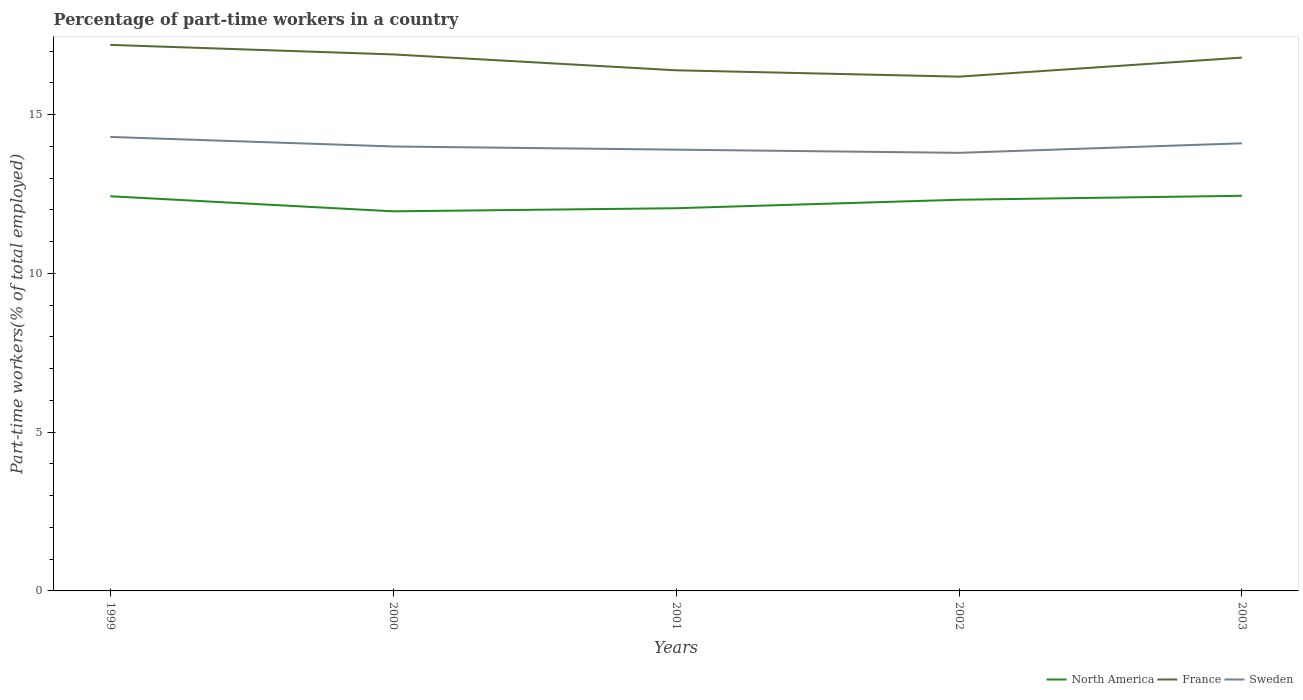Across all years, what is the maximum percentage of part-time workers in Sweden?
Give a very brief answer. 13.8. What is the total percentage of part-time workers in France in the graph?
Provide a succinct answer. 0.7. What is the difference between the highest and the second highest percentage of part-time workers in North America?
Make the answer very short. 0.49. What is the difference between the highest and the lowest percentage of part-time workers in France?
Keep it short and to the point. 3. Is the percentage of part-time workers in Sweden strictly greater than the percentage of part-time workers in North America over the years?
Your response must be concise. No. How many years are there in the graph?
Keep it short and to the point. 5. What is the difference between two consecutive major ticks on the Y-axis?
Your answer should be very brief. 5. How many legend labels are there?
Your answer should be compact. 3. How are the legend labels stacked?
Ensure brevity in your answer.  Horizontal. What is the title of the graph?
Provide a succinct answer. Percentage of part-time workers in a country. Does "Dominican Republic" appear as one of the legend labels in the graph?
Your answer should be compact. No. What is the label or title of the X-axis?
Offer a terse response. Years. What is the label or title of the Y-axis?
Your answer should be compact. Part-time workers(% of total employed). What is the Part-time workers(% of total employed) of North America in 1999?
Offer a terse response. 12.43. What is the Part-time workers(% of total employed) in France in 1999?
Offer a very short reply. 17.2. What is the Part-time workers(% of total employed) in Sweden in 1999?
Offer a very short reply. 14.3. What is the Part-time workers(% of total employed) of North America in 2000?
Offer a terse response. 11.96. What is the Part-time workers(% of total employed) of France in 2000?
Your answer should be compact. 16.9. What is the Part-time workers(% of total employed) of North America in 2001?
Ensure brevity in your answer.  12.06. What is the Part-time workers(% of total employed) in France in 2001?
Offer a terse response. 16.4. What is the Part-time workers(% of total employed) of Sweden in 2001?
Offer a terse response. 13.9. What is the Part-time workers(% of total employed) in North America in 2002?
Provide a succinct answer. 12.32. What is the Part-time workers(% of total employed) of France in 2002?
Provide a succinct answer. 16.2. What is the Part-time workers(% of total employed) in Sweden in 2002?
Make the answer very short. 13.8. What is the Part-time workers(% of total employed) in North America in 2003?
Ensure brevity in your answer.  12.45. What is the Part-time workers(% of total employed) in France in 2003?
Provide a short and direct response. 16.8. What is the Part-time workers(% of total employed) of Sweden in 2003?
Keep it short and to the point. 14.1. Across all years, what is the maximum Part-time workers(% of total employed) in North America?
Offer a terse response. 12.45. Across all years, what is the maximum Part-time workers(% of total employed) of France?
Make the answer very short. 17.2. Across all years, what is the maximum Part-time workers(% of total employed) in Sweden?
Keep it short and to the point. 14.3. Across all years, what is the minimum Part-time workers(% of total employed) of North America?
Keep it short and to the point. 11.96. Across all years, what is the minimum Part-time workers(% of total employed) of France?
Offer a very short reply. 16.2. Across all years, what is the minimum Part-time workers(% of total employed) in Sweden?
Keep it short and to the point. 13.8. What is the total Part-time workers(% of total employed) in North America in the graph?
Make the answer very short. 61.21. What is the total Part-time workers(% of total employed) of France in the graph?
Keep it short and to the point. 83.5. What is the total Part-time workers(% of total employed) in Sweden in the graph?
Ensure brevity in your answer.  70.1. What is the difference between the Part-time workers(% of total employed) of North America in 1999 and that in 2000?
Provide a short and direct response. 0.48. What is the difference between the Part-time workers(% of total employed) in North America in 1999 and that in 2001?
Provide a succinct answer. 0.38. What is the difference between the Part-time workers(% of total employed) of Sweden in 1999 and that in 2001?
Provide a short and direct response. 0.4. What is the difference between the Part-time workers(% of total employed) of North America in 1999 and that in 2002?
Your answer should be compact. 0.11. What is the difference between the Part-time workers(% of total employed) in France in 1999 and that in 2002?
Provide a succinct answer. 1. What is the difference between the Part-time workers(% of total employed) of North America in 1999 and that in 2003?
Offer a terse response. -0.01. What is the difference between the Part-time workers(% of total employed) of France in 1999 and that in 2003?
Ensure brevity in your answer.  0.4. What is the difference between the Part-time workers(% of total employed) of North America in 2000 and that in 2001?
Keep it short and to the point. -0.1. What is the difference between the Part-time workers(% of total employed) of Sweden in 2000 and that in 2001?
Your response must be concise. 0.1. What is the difference between the Part-time workers(% of total employed) of North America in 2000 and that in 2002?
Your answer should be very brief. -0.36. What is the difference between the Part-time workers(% of total employed) in North America in 2000 and that in 2003?
Ensure brevity in your answer.  -0.49. What is the difference between the Part-time workers(% of total employed) in North America in 2001 and that in 2002?
Offer a very short reply. -0.27. What is the difference between the Part-time workers(% of total employed) in Sweden in 2001 and that in 2002?
Offer a terse response. 0.1. What is the difference between the Part-time workers(% of total employed) of North America in 2001 and that in 2003?
Your response must be concise. -0.39. What is the difference between the Part-time workers(% of total employed) of France in 2001 and that in 2003?
Ensure brevity in your answer.  -0.4. What is the difference between the Part-time workers(% of total employed) of Sweden in 2001 and that in 2003?
Provide a succinct answer. -0.2. What is the difference between the Part-time workers(% of total employed) in North America in 2002 and that in 2003?
Your answer should be compact. -0.13. What is the difference between the Part-time workers(% of total employed) in Sweden in 2002 and that in 2003?
Keep it short and to the point. -0.3. What is the difference between the Part-time workers(% of total employed) of North America in 1999 and the Part-time workers(% of total employed) of France in 2000?
Make the answer very short. -4.47. What is the difference between the Part-time workers(% of total employed) in North America in 1999 and the Part-time workers(% of total employed) in Sweden in 2000?
Keep it short and to the point. -1.57. What is the difference between the Part-time workers(% of total employed) in North America in 1999 and the Part-time workers(% of total employed) in France in 2001?
Offer a very short reply. -3.97. What is the difference between the Part-time workers(% of total employed) in North America in 1999 and the Part-time workers(% of total employed) in Sweden in 2001?
Offer a terse response. -1.47. What is the difference between the Part-time workers(% of total employed) in France in 1999 and the Part-time workers(% of total employed) in Sweden in 2001?
Give a very brief answer. 3.3. What is the difference between the Part-time workers(% of total employed) in North America in 1999 and the Part-time workers(% of total employed) in France in 2002?
Your answer should be very brief. -3.77. What is the difference between the Part-time workers(% of total employed) in North America in 1999 and the Part-time workers(% of total employed) in Sweden in 2002?
Your answer should be very brief. -1.37. What is the difference between the Part-time workers(% of total employed) of North America in 1999 and the Part-time workers(% of total employed) of France in 2003?
Keep it short and to the point. -4.37. What is the difference between the Part-time workers(% of total employed) in North America in 1999 and the Part-time workers(% of total employed) in Sweden in 2003?
Give a very brief answer. -1.67. What is the difference between the Part-time workers(% of total employed) in North America in 2000 and the Part-time workers(% of total employed) in France in 2001?
Make the answer very short. -4.44. What is the difference between the Part-time workers(% of total employed) of North America in 2000 and the Part-time workers(% of total employed) of Sweden in 2001?
Ensure brevity in your answer.  -1.94. What is the difference between the Part-time workers(% of total employed) in North America in 2000 and the Part-time workers(% of total employed) in France in 2002?
Provide a succinct answer. -4.24. What is the difference between the Part-time workers(% of total employed) in North America in 2000 and the Part-time workers(% of total employed) in Sweden in 2002?
Your answer should be compact. -1.84. What is the difference between the Part-time workers(% of total employed) in North America in 2000 and the Part-time workers(% of total employed) in France in 2003?
Your answer should be very brief. -4.84. What is the difference between the Part-time workers(% of total employed) in North America in 2000 and the Part-time workers(% of total employed) in Sweden in 2003?
Make the answer very short. -2.14. What is the difference between the Part-time workers(% of total employed) in France in 2000 and the Part-time workers(% of total employed) in Sweden in 2003?
Your response must be concise. 2.8. What is the difference between the Part-time workers(% of total employed) of North America in 2001 and the Part-time workers(% of total employed) of France in 2002?
Give a very brief answer. -4.14. What is the difference between the Part-time workers(% of total employed) of North America in 2001 and the Part-time workers(% of total employed) of Sweden in 2002?
Your answer should be compact. -1.74. What is the difference between the Part-time workers(% of total employed) in France in 2001 and the Part-time workers(% of total employed) in Sweden in 2002?
Ensure brevity in your answer.  2.6. What is the difference between the Part-time workers(% of total employed) in North America in 2001 and the Part-time workers(% of total employed) in France in 2003?
Offer a terse response. -4.74. What is the difference between the Part-time workers(% of total employed) of North America in 2001 and the Part-time workers(% of total employed) of Sweden in 2003?
Offer a terse response. -2.04. What is the difference between the Part-time workers(% of total employed) of France in 2001 and the Part-time workers(% of total employed) of Sweden in 2003?
Offer a terse response. 2.3. What is the difference between the Part-time workers(% of total employed) in North America in 2002 and the Part-time workers(% of total employed) in France in 2003?
Your answer should be compact. -4.48. What is the difference between the Part-time workers(% of total employed) in North America in 2002 and the Part-time workers(% of total employed) in Sweden in 2003?
Provide a succinct answer. -1.78. What is the average Part-time workers(% of total employed) in North America per year?
Offer a terse response. 12.24. What is the average Part-time workers(% of total employed) of Sweden per year?
Provide a succinct answer. 14.02. In the year 1999, what is the difference between the Part-time workers(% of total employed) of North America and Part-time workers(% of total employed) of France?
Your response must be concise. -4.77. In the year 1999, what is the difference between the Part-time workers(% of total employed) in North America and Part-time workers(% of total employed) in Sweden?
Offer a very short reply. -1.87. In the year 2000, what is the difference between the Part-time workers(% of total employed) of North America and Part-time workers(% of total employed) of France?
Your response must be concise. -4.94. In the year 2000, what is the difference between the Part-time workers(% of total employed) in North America and Part-time workers(% of total employed) in Sweden?
Provide a short and direct response. -2.04. In the year 2001, what is the difference between the Part-time workers(% of total employed) in North America and Part-time workers(% of total employed) in France?
Offer a terse response. -4.34. In the year 2001, what is the difference between the Part-time workers(% of total employed) in North America and Part-time workers(% of total employed) in Sweden?
Ensure brevity in your answer.  -1.84. In the year 2002, what is the difference between the Part-time workers(% of total employed) of North America and Part-time workers(% of total employed) of France?
Offer a very short reply. -3.88. In the year 2002, what is the difference between the Part-time workers(% of total employed) in North America and Part-time workers(% of total employed) in Sweden?
Give a very brief answer. -1.48. In the year 2002, what is the difference between the Part-time workers(% of total employed) in France and Part-time workers(% of total employed) in Sweden?
Provide a succinct answer. 2.4. In the year 2003, what is the difference between the Part-time workers(% of total employed) in North America and Part-time workers(% of total employed) in France?
Your answer should be very brief. -4.35. In the year 2003, what is the difference between the Part-time workers(% of total employed) of North America and Part-time workers(% of total employed) of Sweden?
Offer a terse response. -1.65. In the year 2003, what is the difference between the Part-time workers(% of total employed) in France and Part-time workers(% of total employed) in Sweden?
Your response must be concise. 2.7. What is the ratio of the Part-time workers(% of total employed) in North America in 1999 to that in 2000?
Your answer should be very brief. 1.04. What is the ratio of the Part-time workers(% of total employed) in France in 1999 to that in 2000?
Offer a very short reply. 1.02. What is the ratio of the Part-time workers(% of total employed) in Sweden in 1999 to that in 2000?
Make the answer very short. 1.02. What is the ratio of the Part-time workers(% of total employed) of North America in 1999 to that in 2001?
Your answer should be compact. 1.03. What is the ratio of the Part-time workers(% of total employed) of France in 1999 to that in 2001?
Provide a short and direct response. 1.05. What is the ratio of the Part-time workers(% of total employed) in Sweden in 1999 to that in 2001?
Make the answer very short. 1.03. What is the ratio of the Part-time workers(% of total employed) in North America in 1999 to that in 2002?
Offer a terse response. 1.01. What is the ratio of the Part-time workers(% of total employed) in France in 1999 to that in 2002?
Ensure brevity in your answer.  1.06. What is the ratio of the Part-time workers(% of total employed) of Sweden in 1999 to that in 2002?
Your answer should be compact. 1.04. What is the ratio of the Part-time workers(% of total employed) in France in 1999 to that in 2003?
Make the answer very short. 1.02. What is the ratio of the Part-time workers(% of total employed) in Sweden in 1999 to that in 2003?
Your answer should be compact. 1.01. What is the ratio of the Part-time workers(% of total employed) of North America in 2000 to that in 2001?
Offer a terse response. 0.99. What is the ratio of the Part-time workers(% of total employed) of France in 2000 to that in 2001?
Give a very brief answer. 1.03. What is the ratio of the Part-time workers(% of total employed) in North America in 2000 to that in 2002?
Your answer should be compact. 0.97. What is the ratio of the Part-time workers(% of total employed) of France in 2000 to that in 2002?
Offer a terse response. 1.04. What is the ratio of the Part-time workers(% of total employed) of Sweden in 2000 to that in 2002?
Ensure brevity in your answer.  1.01. What is the ratio of the Part-time workers(% of total employed) in North America in 2000 to that in 2003?
Ensure brevity in your answer.  0.96. What is the ratio of the Part-time workers(% of total employed) in Sweden in 2000 to that in 2003?
Your answer should be compact. 0.99. What is the ratio of the Part-time workers(% of total employed) in North America in 2001 to that in 2002?
Ensure brevity in your answer.  0.98. What is the ratio of the Part-time workers(% of total employed) of France in 2001 to that in 2002?
Ensure brevity in your answer.  1.01. What is the ratio of the Part-time workers(% of total employed) of Sweden in 2001 to that in 2002?
Keep it short and to the point. 1.01. What is the ratio of the Part-time workers(% of total employed) of North America in 2001 to that in 2003?
Make the answer very short. 0.97. What is the ratio of the Part-time workers(% of total employed) of France in 2001 to that in 2003?
Provide a succinct answer. 0.98. What is the ratio of the Part-time workers(% of total employed) of Sweden in 2001 to that in 2003?
Provide a short and direct response. 0.99. What is the ratio of the Part-time workers(% of total employed) in North America in 2002 to that in 2003?
Offer a terse response. 0.99. What is the ratio of the Part-time workers(% of total employed) of France in 2002 to that in 2003?
Provide a succinct answer. 0.96. What is the ratio of the Part-time workers(% of total employed) of Sweden in 2002 to that in 2003?
Ensure brevity in your answer.  0.98. What is the difference between the highest and the second highest Part-time workers(% of total employed) of North America?
Your answer should be very brief. 0.01. What is the difference between the highest and the second highest Part-time workers(% of total employed) of Sweden?
Provide a short and direct response. 0.2. What is the difference between the highest and the lowest Part-time workers(% of total employed) in North America?
Ensure brevity in your answer.  0.49. 